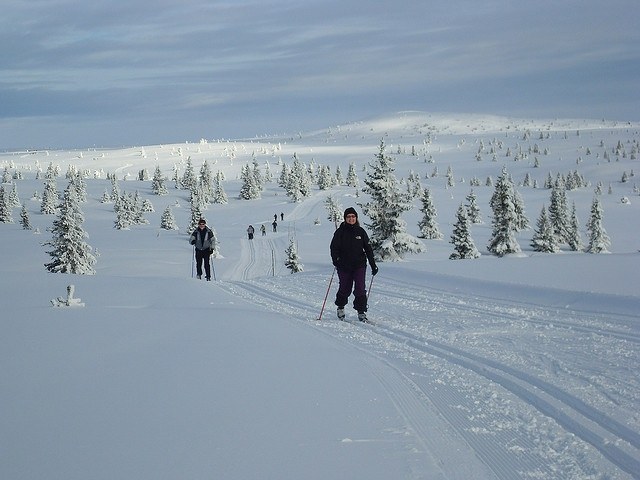Describe the objects in this image and their specific colors. I can see people in darkgray, black, gray, and brown tones, people in darkgray, black, gray, and darkblue tones, skis in darkgray and gray tones, people in darkgray, black, and gray tones, and skis in darkgray, black, and gray tones in this image. 